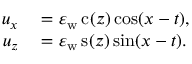<formula> <loc_0><loc_0><loc_500><loc_500>\begin{array} { r l } { u _ { x } } & = \varepsilon _ { w } \, c ( z ) \cos ( x - t ) , } \\ { u _ { z } } & = \varepsilon _ { w } \, s ( z ) \sin ( x - t ) . } \end{array}</formula> 